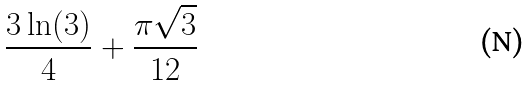Convert formula to latex. <formula><loc_0><loc_0><loc_500><loc_500>\frac { 3 \ln ( 3 ) } { 4 } + \frac { \pi \sqrt { 3 } } { 1 2 }</formula> 